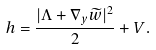<formula> <loc_0><loc_0><loc_500><loc_500>h = \frac { | \Lambda + \nabla _ { y } \widetilde { w } | ^ { 2 } } { 2 } + V .</formula> 